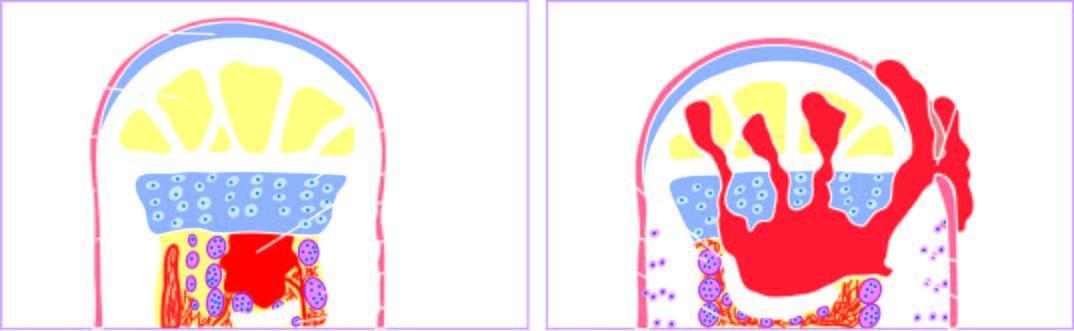what produces a draining sinus?
Answer the question using a single word or phrase. Extension of infection into the joint space 